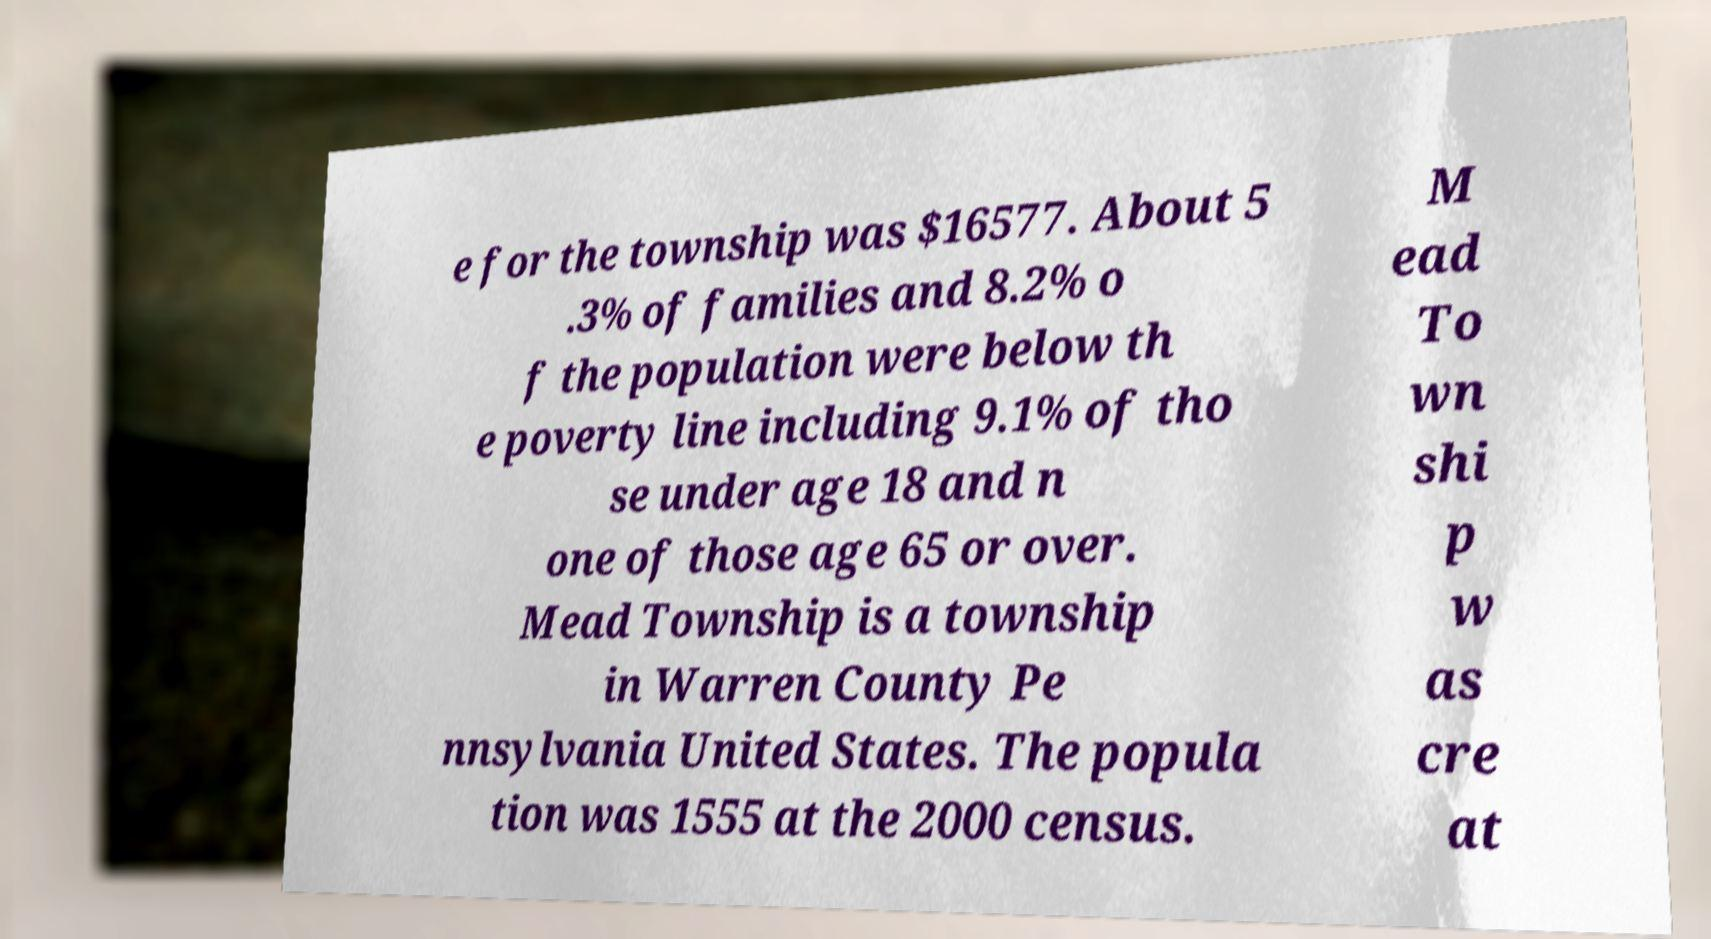Can you read and provide the text displayed in the image?This photo seems to have some interesting text. Can you extract and type it out for me? e for the township was $16577. About 5 .3% of families and 8.2% o f the population were below th e poverty line including 9.1% of tho se under age 18 and n one of those age 65 or over. Mead Township is a township in Warren County Pe nnsylvania United States. The popula tion was 1555 at the 2000 census. M ead To wn shi p w as cre at 